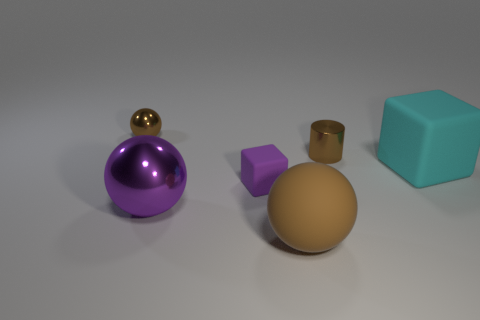What shape is the brown matte object?
Give a very brief answer. Sphere. Are there more brown things behind the large purple shiny ball than tiny metal spheres in front of the large matte block?
Your response must be concise. Yes. What number of other things are there of the same size as the cylinder?
Offer a terse response. 2. What is the small object that is both left of the small brown shiny cylinder and in front of the small brown ball made of?
Provide a short and direct response. Rubber. What is the material of the small object that is the same shape as the large purple metal object?
Your answer should be compact. Metal. There is a block that is to the left of the large brown object left of the tiny brown cylinder; what number of big brown rubber balls are right of it?
Your answer should be very brief. 1. Is there any other thing of the same color as the small ball?
Give a very brief answer. Yes. How many brown spheres are both right of the purple rubber block and to the left of the big metal object?
Ensure brevity in your answer.  0. There is a object right of the brown metal cylinder; is it the same size as the brown object in front of the cyan matte block?
Keep it short and to the point. Yes. What number of objects are either spheres that are in front of the large purple metallic ball or brown blocks?
Make the answer very short. 1. 